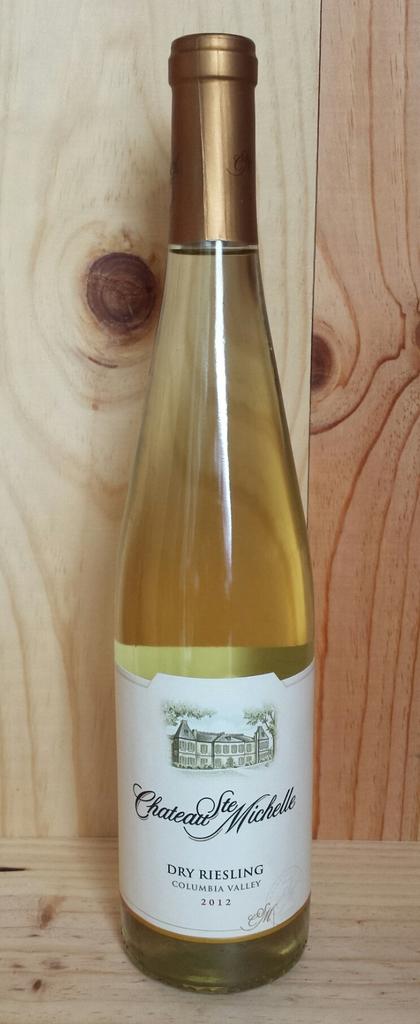What type of wine is this?
Ensure brevity in your answer.  Dry riesling. 